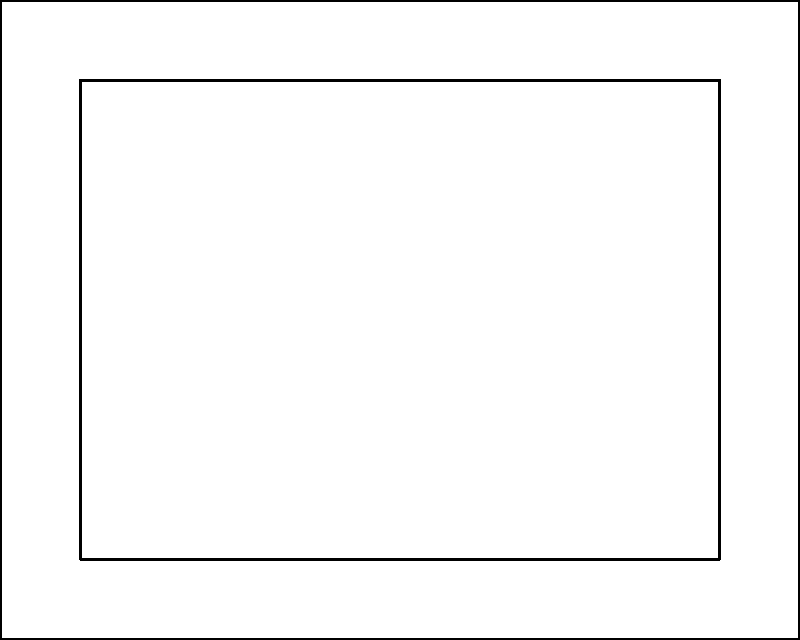Given the site plan diagram, which location (A, B, or C) is optimal for placing a dumpster to minimize waste transportation distance and maximize accessibility for both workers and pickup trucks? Explain your reasoning considering factors such as proximity to the building, access to the road, and potential obstructions. To determine the optimal dumpster placement, we need to consider several factors:

1. Proximity to the building: The dumpster should be close enough to the building to minimize the distance workers need to travel with waste materials.

2. Accessibility for pickup trucks: The dumpster should be easily accessible from the access road for efficient waste removal.

3. Minimizing obstructions: The dumpster should not block pathways or interfere with construction activities.

4. Safety considerations: The location should not create hazards for workers or vehicles moving around the site.

Analyzing the options:

A. Located near the top-right corner of the building:
   - Close to the building, minimizing worker travel distance
   - Adjacent to the access road, allowing easy pickup
   - Does not obstruct pathways around the building
   - Provides a clear line of sight for safety

B. Located at the bottom of the site:
   - Far from the building, increasing worker travel distance
   - Access to the road is obstructed by the building
   - May interfere with activities at the front of the building

C. Located on the left side of the building:
   - Close to the building, but not optimal for all areas
   - Far from the access road, making pickup difficult
   - May obstruct pathways on the left side of the building

Considering these factors, location A is the optimal choice for dumpster placement. It provides the best balance of proximity to the building, accessibility for pickup trucks, and minimal obstruction to site activities.
Answer: Location A 